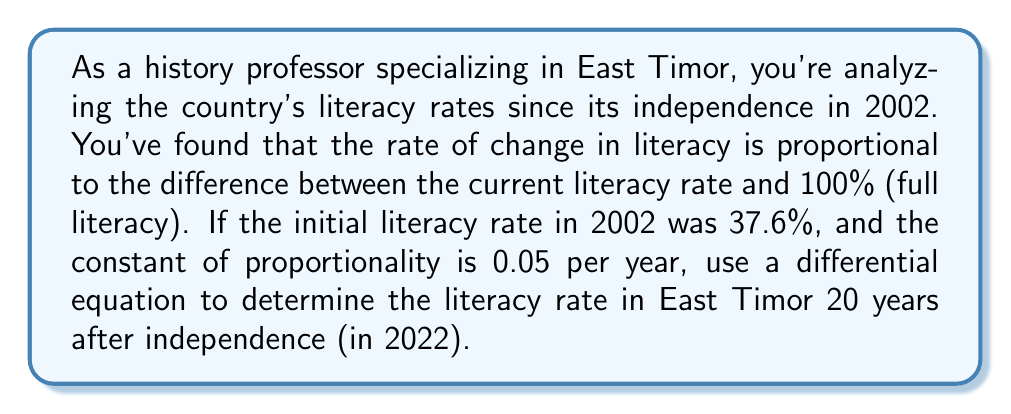Show me your answer to this math problem. Let's approach this step-by-step:

1) Let $L(t)$ be the literacy rate at time $t$, where $t$ is measured in years since 2002.

2) The rate of change in literacy is proportional to the difference between 100% and the current rate. This can be expressed as a differential equation:

   $$\frac{dL}{dt} = k(100 - L)$$

   where $k$ is the constant of proportionality, given as 0.05 per year.

3) This is a separable differential equation. Let's separate the variables:

   $$\frac{dL}{100 - L} = k dt$$

4) Integrating both sides:

   $$\int \frac{dL}{100 - L} = \int k dt$$

   $$-\ln|100 - L| = kt + C$$

5) Solving for $L$:

   $$100 - L = e^{-(kt + C)} = Ae^{-kt}$$
   $$L = 100 - Ae^{-kt}$$

   where $A = e^{-C}$ is a constant we'll determine from the initial condition.

6) Using the initial condition $L(0) = 37.6$:

   $$37.6 = 100 - A$$
   $$A = 62.4$$

7) So our solution is:

   $$L(t) = 100 - 62.4e^{-0.05t}$$

8) To find the literacy rate after 20 years, we calculate $L(20)$:

   $$L(20) = 100 - 62.4e^{-0.05(20)}$$
   $$= 100 - 62.4e^{-1}$$
   $$= 100 - 62.4(0.3679)$$
   $$= 100 - 22.9566$$
   $$= 77.0434$$

Therefore, the literacy rate in East Timor in 2022, according to this model, would be approximately 77.04%.
Answer: The literacy rate in East Timor in 2022, 20 years after independence, is approximately 77.04%. 